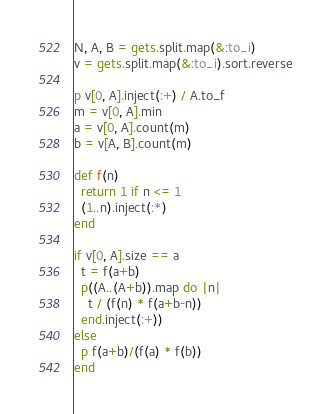Convert code to text. <code><loc_0><loc_0><loc_500><loc_500><_Ruby_>N, A, B = gets.split.map(&:to_i)
v = gets.split.map(&:to_i).sort.reverse

p v[0, A].inject(:+) / A.to_f
m = v[0, A].min
a = v[0, A].count(m)
b = v[A, B].count(m)

def f(n)
  return 1 if n <= 1
  (1..n).inject(:*)
end

if v[0, A].size == a
  t = f(a+b)
  p((A..(A+b)).map do |n|
    t / (f(n) * f(a+b-n))
  end.inject(:+))
else
  p f(a+b)/(f(a) * f(b))
end
</code> 